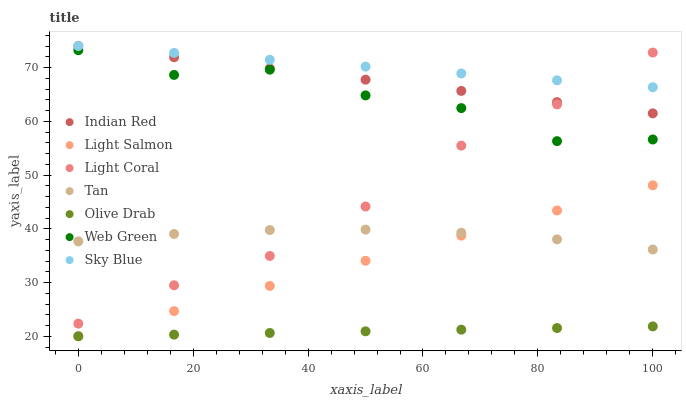Does Olive Drab have the minimum area under the curve?
Answer yes or no. Yes. Does Sky Blue have the maximum area under the curve?
Answer yes or no. Yes. Does Web Green have the minimum area under the curve?
Answer yes or no. No. Does Web Green have the maximum area under the curve?
Answer yes or no. No. Is Olive Drab the smoothest?
Answer yes or no. Yes. Is Web Green the roughest?
Answer yes or no. Yes. Is Light Coral the smoothest?
Answer yes or no. No. Is Light Coral the roughest?
Answer yes or no. No. Does Light Salmon have the lowest value?
Answer yes or no. Yes. Does Web Green have the lowest value?
Answer yes or no. No. Does Sky Blue have the highest value?
Answer yes or no. Yes. Does Web Green have the highest value?
Answer yes or no. No. Is Olive Drab less than Light Coral?
Answer yes or no. Yes. Is Web Green greater than Olive Drab?
Answer yes or no. Yes. Does Tan intersect Light Salmon?
Answer yes or no. Yes. Is Tan less than Light Salmon?
Answer yes or no. No. Is Tan greater than Light Salmon?
Answer yes or no. No. Does Olive Drab intersect Light Coral?
Answer yes or no. No. 